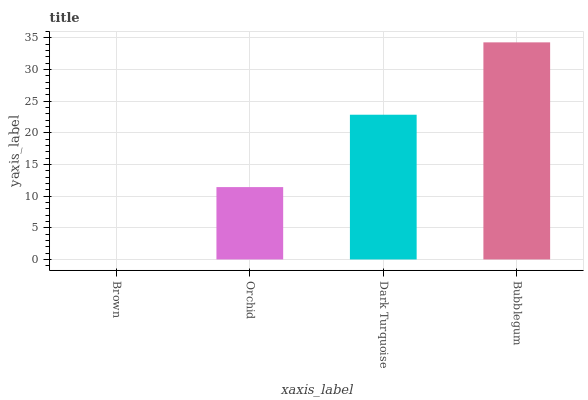Is Brown the minimum?
Answer yes or no. Yes. Is Bubblegum the maximum?
Answer yes or no. Yes. Is Orchid the minimum?
Answer yes or no. No. Is Orchid the maximum?
Answer yes or no. No. Is Orchid greater than Brown?
Answer yes or no. Yes. Is Brown less than Orchid?
Answer yes or no. Yes. Is Brown greater than Orchid?
Answer yes or no. No. Is Orchid less than Brown?
Answer yes or no. No. Is Dark Turquoise the high median?
Answer yes or no. Yes. Is Orchid the low median?
Answer yes or no. Yes. Is Bubblegum the high median?
Answer yes or no. No. Is Brown the low median?
Answer yes or no. No. 